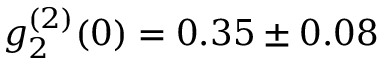<formula> <loc_0><loc_0><loc_500><loc_500>g _ { 2 } ^ { ( 2 ) } ( 0 ) = 0 . 3 5 \pm 0 . 0 8</formula> 